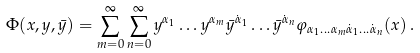Convert formula to latex. <formula><loc_0><loc_0><loc_500><loc_500>\Phi ( x , y , \bar { y } ) = \sum _ { m = 0 } ^ { \infty } \sum _ { n = 0 } ^ { \infty } y ^ { \alpha _ { 1 } } \dots y ^ { \alpha _ { m } } \bar { y } ^ { \dot { \alpha } _ { 1 } } \dots \bar { y } ^ { \dot { \alpha } _ { n } } \varphi _ { \alpha _ { 1 } \dots \alpha _ { m } \dot { \alpha } _ { 1 } \dots \dot { \alpha } _ { n } } ( x ) \, .</formula> 